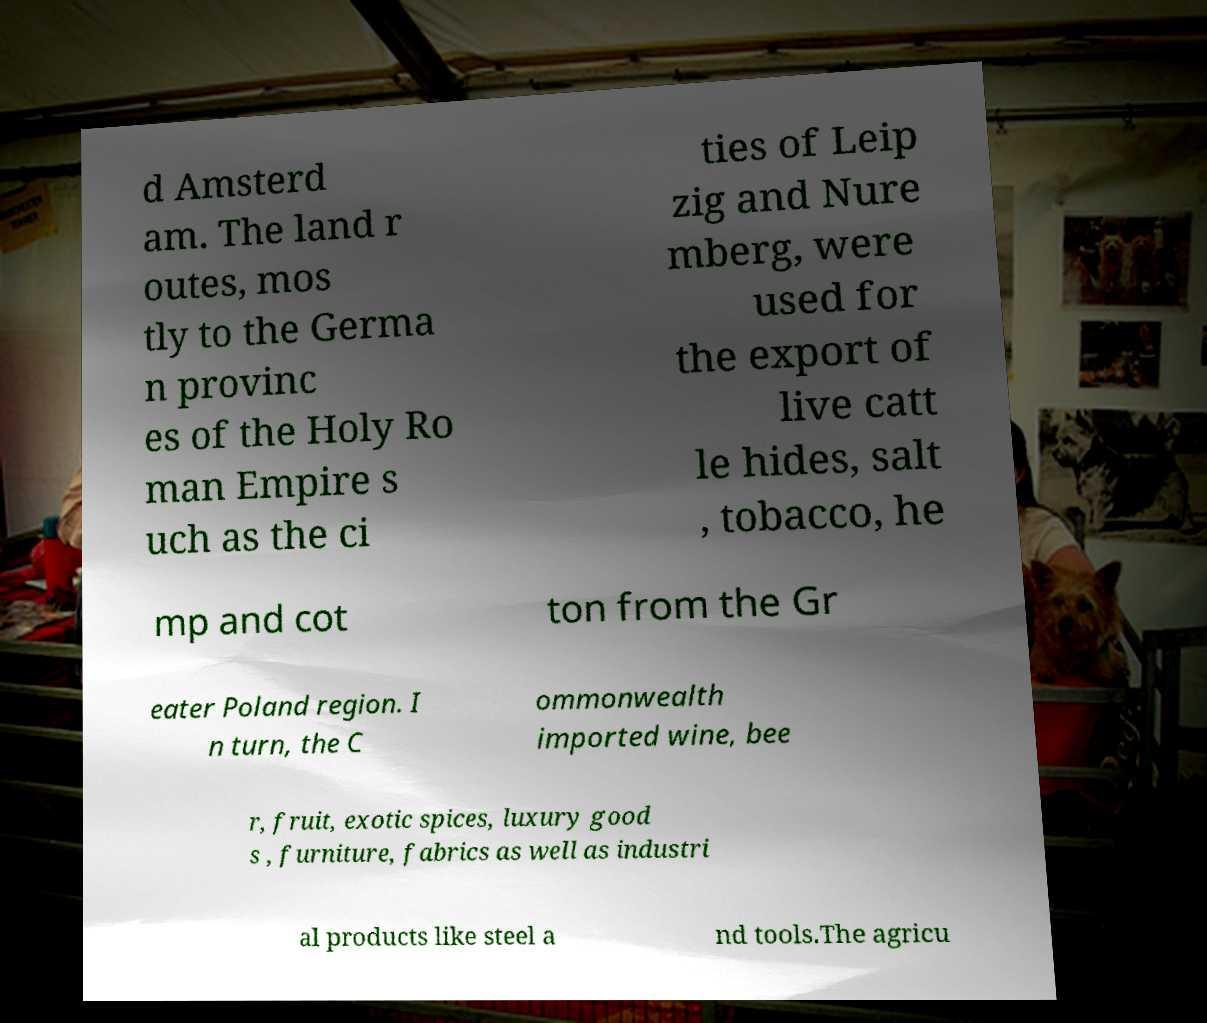Please read and relay the text visible in this image. What does it say? d Amsterd am. The land r outes, mos tly to the Germa n provinc es of the Holy Ro man Empire s uch as the ci ties of Leip zig and Nure mberg, were used for the export of live catt le hides, salt , tobacco, he mp and cot ton from the Gr eater Poland region. I n turn, the C ommonwealth imported wine, bee r, fruit, exotic spices, luxury good s , furniture, fabrics as well as industri al products like steel a nd tools.The agricu 